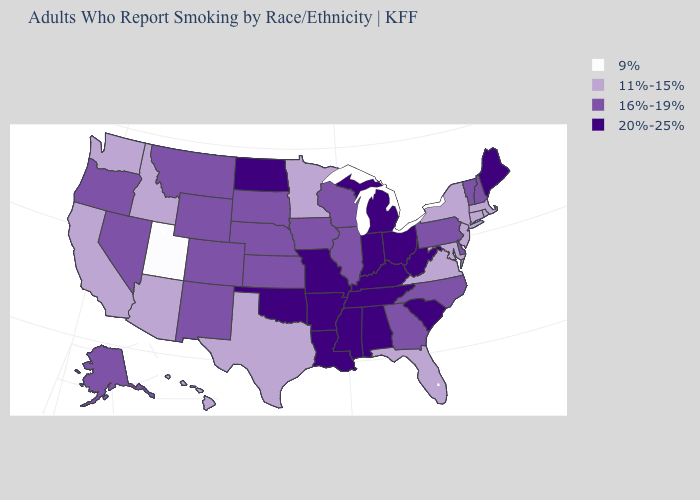Name the states that have a value in the range 9%?
Keep it brief. Utah. Name the states that have a value in the range 11%-15%?
Give a very brief answer. Arizona, California, Connecticut, Florida, Hawaii, Idaho, Maryland, Massachusetts, Minnesota, New Jersey, New York, Rhode Island, Texas, Virginia, Washington. How many symbols are there in the legend?
Keep it brief. 4. What is the lowest value in the USA?
Concise answer only. 9%. Which states have the lowest value in the MidWest?
Short answer required. Minnesota. Does Alaska have the highest value in the USA?
Write a very short answer. No. Does Alabama have the highest value in the South?
Be succinct. Yes. Name the states that have a value in the range 16%-19%?
Concise answer only. Alaska, Colorado, Delaware, Georgia, Illinois, Iowa, Kansas, Montana, Nebraska, Nevada, New Hampshire, New Mexico, North Carolina, Oregon, Pennsylvania, South Dakota, Vermont, Wisconsin, Wyoming. Name the states that have a value in the range 20%-25%?
Answer briefly. Alabama, Arkansas, Indiana, Kentucky, Louisiana, Maine, Michigan, Mississippi, Missouri, North Dakota, Ohio, Oklahoma, South Carolina, Tennessee, West Virginia. Does South Dakota have a lower value than North Dakota?
Concise answer only. Yes. What is the lowest value in states that border Texas?
Keep it brief. 16%-19%. What is the lowest value in states that border Kentucky?
Concise answer only. 11%-15%. Name the states that have a value in the range 20%-25%?
Short answer required. Alabama, Arkansas, Indiana, Kentucky, Louisiana, Maine, Michigan, Mississippi, Missouri, North Dakota, Ohio, Oklahoma, South Carolina, Tennessee, West Virginia. Name the states that have a value in the range 16%-19%?
Short answer required. Alaska, Colorado, Delaware, Georgia, Illinois, Iowa, Kansas, Montana, Nebraska, Nevada, New Hampshire, New Mexico, North Carolina, Oregon, Pennsylvania, South Dakota, Vermont, Wisconsin, Wyoming. Name the states that have a value in the range 11%-15%?
Answer briefly. Arizona, California, Connecticut, Florida, Hawaii, Idaho, Maryland, Massachusetts, Minnesota, New Jersey, New York, Rhode Island, Texas, Virginia, Washington. 